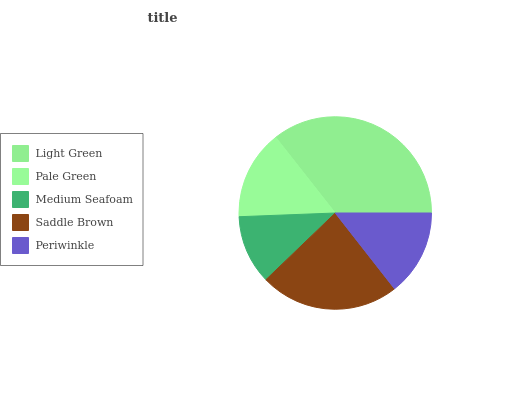Is Medium Seafoam the minimum?
Answer yes or no. Yes. Is Light Green the maximum?
Answer yes or no. Yes. Is Pale Green the minimum?
Answer yes or no. No. Is Pale Green the maximum?
Answer yes or no. No. Is Light Green greater than Pale Green?
Answer yes or no. Yes. Is Pale Green less than Light Green?
Answer yes or no. Yes. Is Pale Green greater than Light Green?
Answer yes or no. No. Is Light Green less than Pale Green?
Answer yes or no. No. Is Pale Green the high median?
Answer yes or no. Yes. Is Pale Green the low median?
Answer yes or no. Yes. Is Periwinkle the high median?
Answer yes or no. No. Is Light Green the low median?
Answer yes or no. No. 